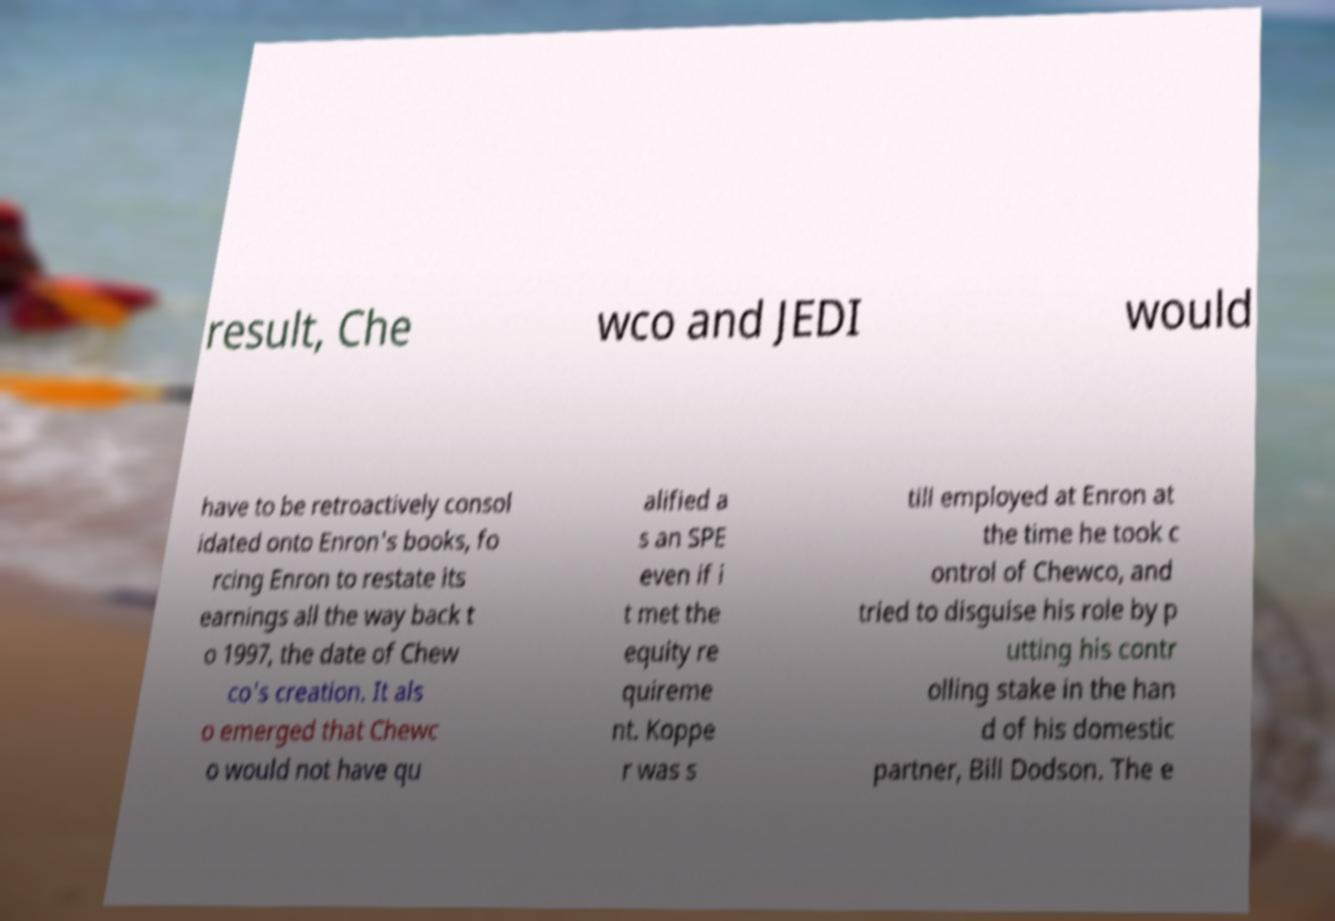Can you accurately transcribe the text from the provided image for me? result, Che wco and JEDI would have to be retroactively consol idated onto Enron's books, fo rcing Enron to restate its earnings all the way back t o 1997, the date of Chew co's creation. It als o emerged that Chewc o would not have qu alified a s an SPE even if i t met the equity re quireme nt. Koppe r was s till employed at Enron at the time he took c ontrol of Chewco, and tried to disguise his role by p utting his contr olling stake in the han d of his domestic partner, Bill Dodson. The e 